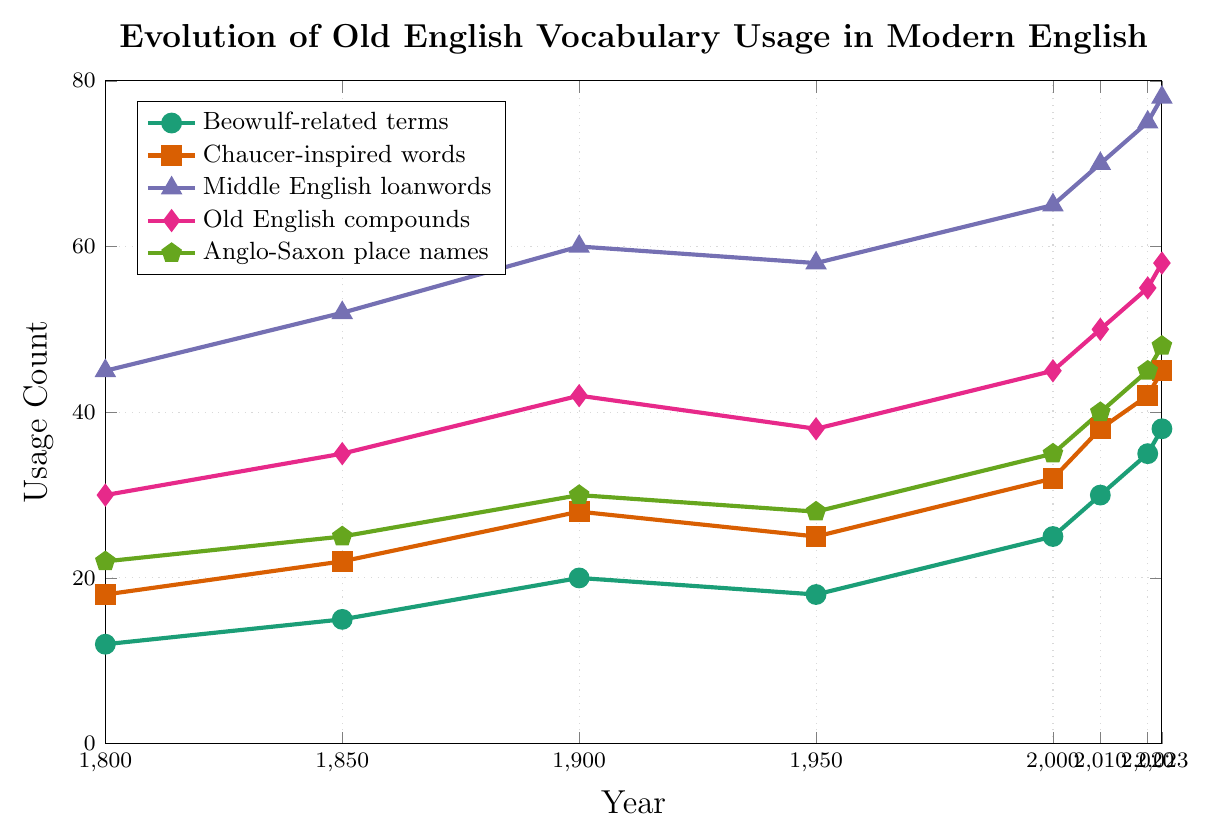which category showed the highest usage count in 2023? By looking at the chart, one needs to locate the highest point on the vertical axis corresponding to the year 2023. Middle English loanwords reach the highest point at 78.
Answer: Middle English loanwords what is the total usage count of Beowulf-related terms and Anglo-Saxon place names in 2023? The usage count of Beowulf-related terms in 2023 is 38, and for Anglo-Saxon place names, it is 48. Adding these two values together gives 38 + 48 = 86.
Answer: 86 how did the usage of Chaucer-inspired words change between 1900 and 1950? The usage count of Chaucer-inspired words in 1900 was 28, and in 1950 it was 25. The change is 25 - 28, which results in a decrease of 3.
Answer: Decrease by 3 which category saw the largest increase in usage count from 1800 to 2023? To determine this, subtract the 1800 count from the 2023 count for each category and identify the largest difference. Middle English loanwords increased from 45 in 1800 to 78 in 2023, giving an increase of 33. No other category has a larger difference.
Answer: Middle English loanwords compare the usage of Old English compounds and Chaucer-inspired words in 2000. Which was more prevalent? Checking the data points for the year 2000, Old English compounds had a usage count of 45, and Chaucer-inspired words had a count of 32. Old English compounds were more prevalent.
Answer: Old English compounds what is the average usage count of Beowulf-related terms over the years provided? The data points for Beowulf-related terms are 12, 15, 20, 18, 25, 30, 35, and 38. Sum these values to get 193, and then divide by the number of data points, which is 8. The average is 193 / 8 = 24.125.
Answer: 24.125 between 2010 and 2023, which category experienced the smallest increase in usage count? Calculate the increase for each category between 2010 and 2023: Beowulf-related terms increased by 8 (38-30), Chaucer-inspired words by 7 (45-38), Middle English loanwords by 8 (78-70), Old English compounds by 8 (58-50), and Anglo-Saxon place names by 8 (48-40). The smallest increase is for Chaucer-inspired words, which is 7.
Answer: Chaucer-inspired words what was the trend in the usage of Anglo-Saxon place names from 1900 to 1950? Observing the chart, the usage of Anglo-Saxon place names increased from 30 in 1900 to 28 in 1950. This reveals a downward trend with a decrease of 2.
Answer: Downward trend what is the cumulative usage count of all categories in the year 2000? Adding the values for each category in 2000: Beowulf-related terms (25), Chaucer-inspired words (32), Middle English loanwords (65), Old English compounds (45), and Anglo-Saxon place names (35). The total is 25 + 32 + 65 + 45 + 35 = 202.
Answer: 202 